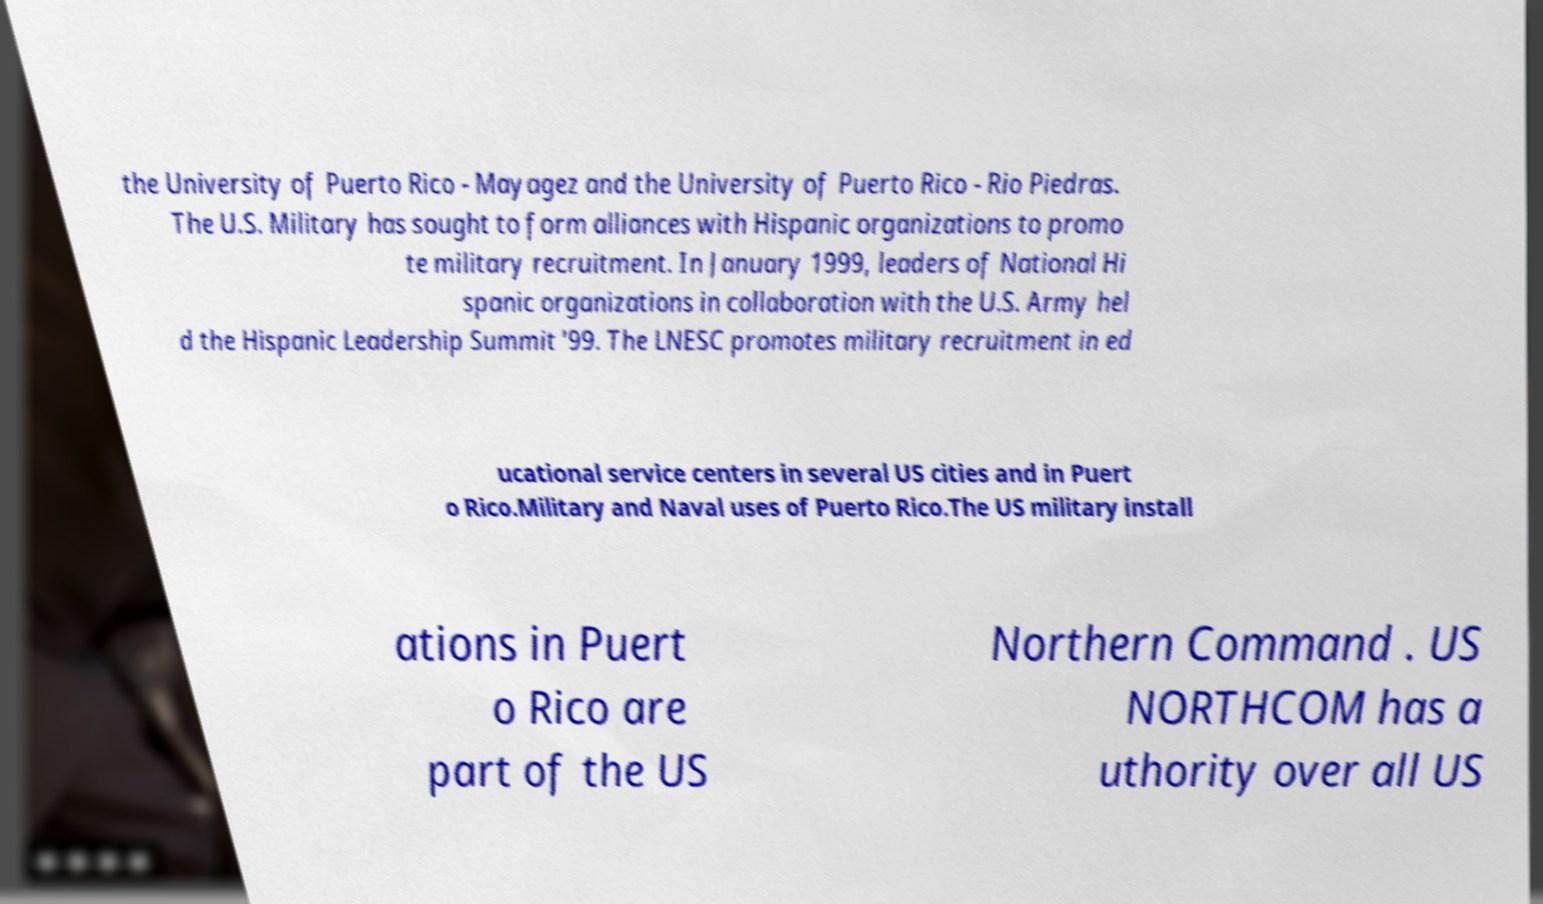I need the written content from this picture converted into text. Can you do that? the University of Puerto Rico - Mayagez and the University of Puerto Rico - Rio Piedras. The U.S. Military has sought to form alliances with Hispanic organizations to promo te military recruitment. In January 1999, leaders of National Hi spanic organizations in collaboration with the U.S. Army hel d the Hispanic Leadership Summit '99. The LNESC promotes military recruitment in ed ucational service centers in several US cities and in Puert o Rico.Military and Naval uses of Puerto Rico.The US military install ations in Puert o Rico are part of the US Northern Command . US NORTHCOM has a uthority over all US 